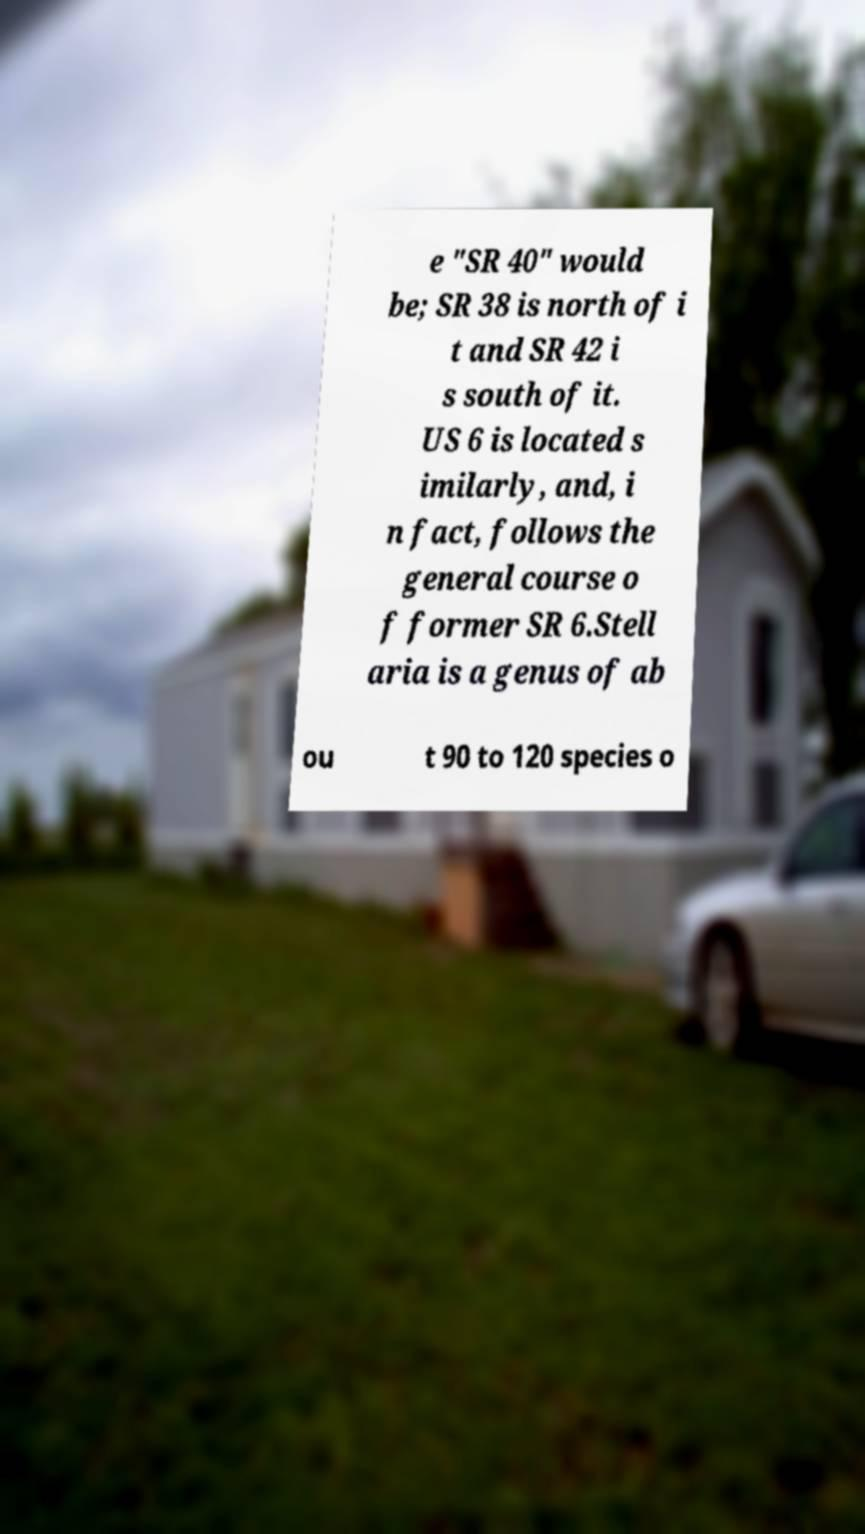Please identify and transcribe the text found in this image. e "SR 40" would be; SR 38 is north of i t and SR 42 i s south of it. US 6 is located s imilarly, and, i n fact, follows the general course o f former SR 6.Stell aria is a genus of ab ou t 90 to 120 species o 